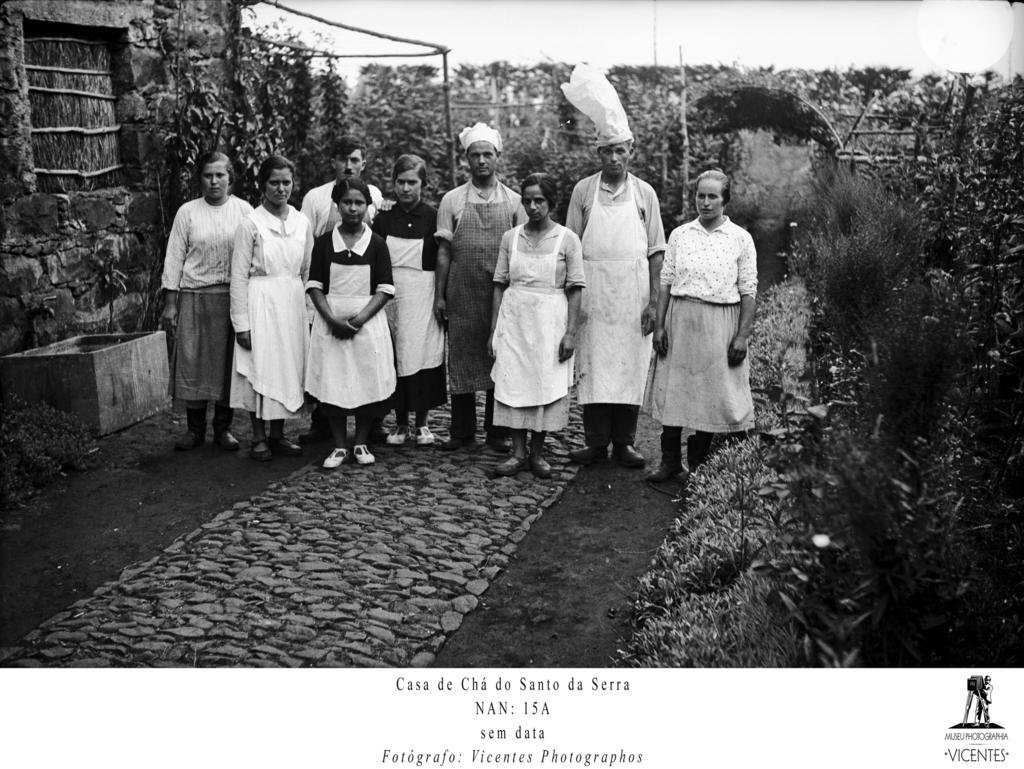What is happening in the center of the image? There are people standing in the middle of the image. What can be seen in the background of the image? There are trees surrounding the area in the image. What type of arch can be seen in the image? There is no arch present in the image; it only features people standing in the middle and trees surrounding the area. 